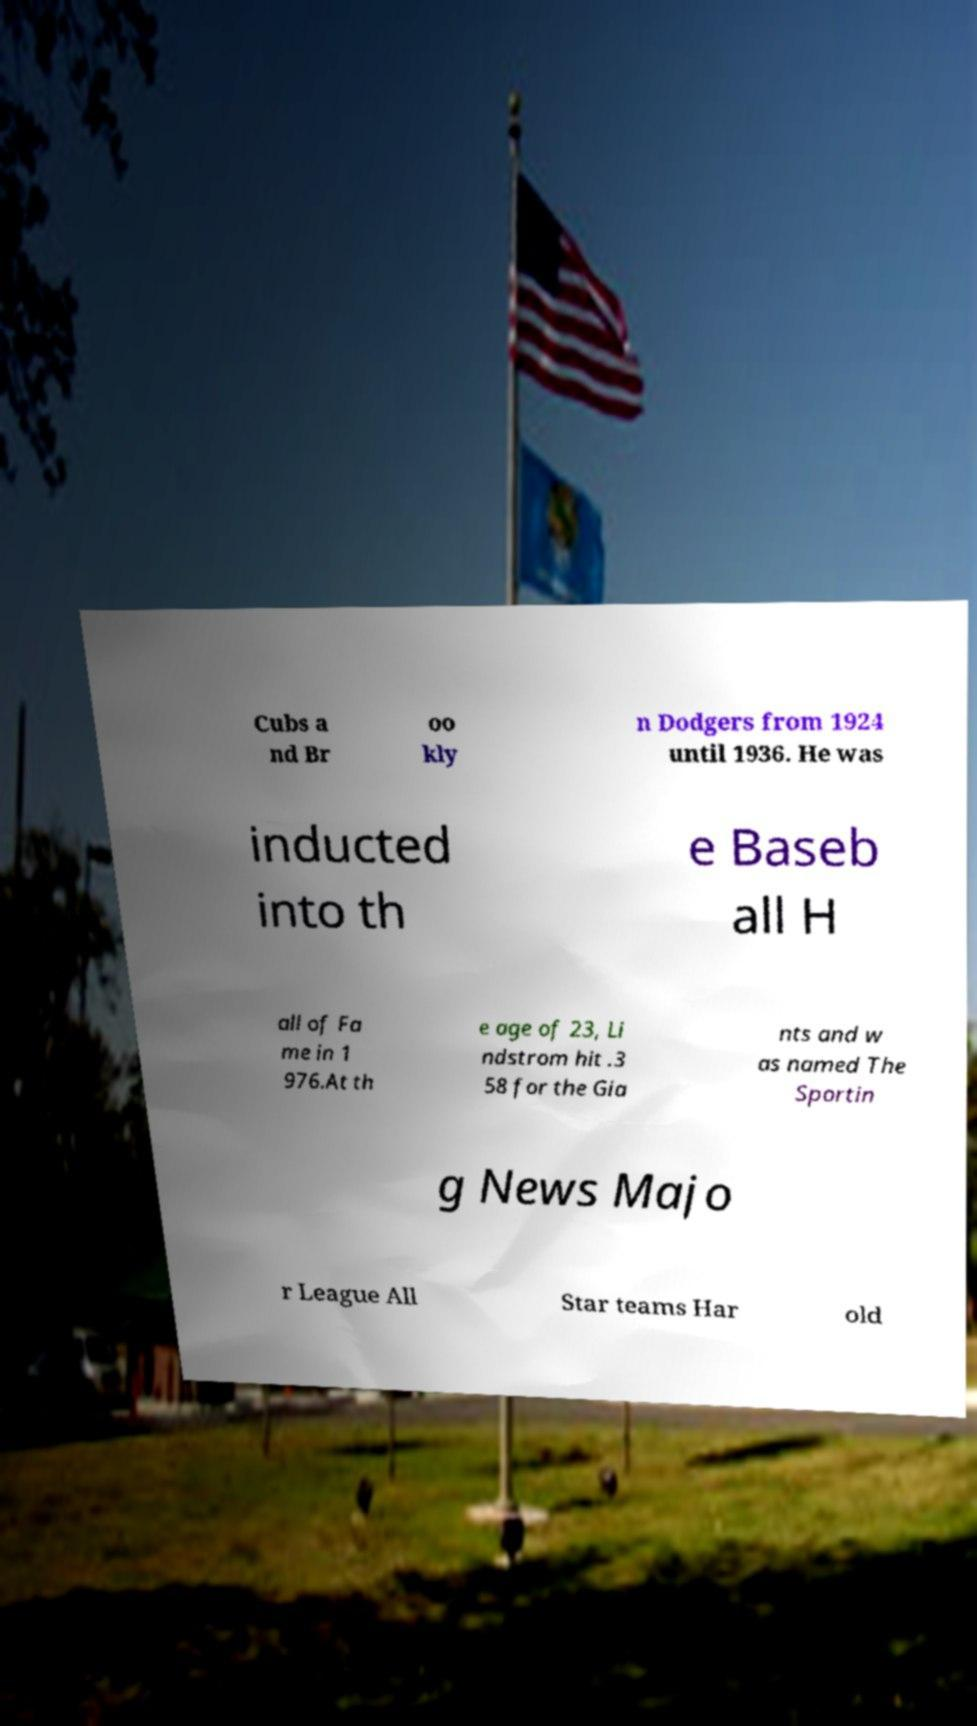There's text embedded in this image that I need extracted. Can you transcribe it verbatim? Cubs a nd Br oo kly n Dodgers from 1924 until 1936. He was inducted into th e Baseb all H all of Fa me in 1 976.At th e age of 23, Li ndstrom hit .3 58 for the Gia nts and w as named The Sportin g News Majo r League All Star teams Har old 